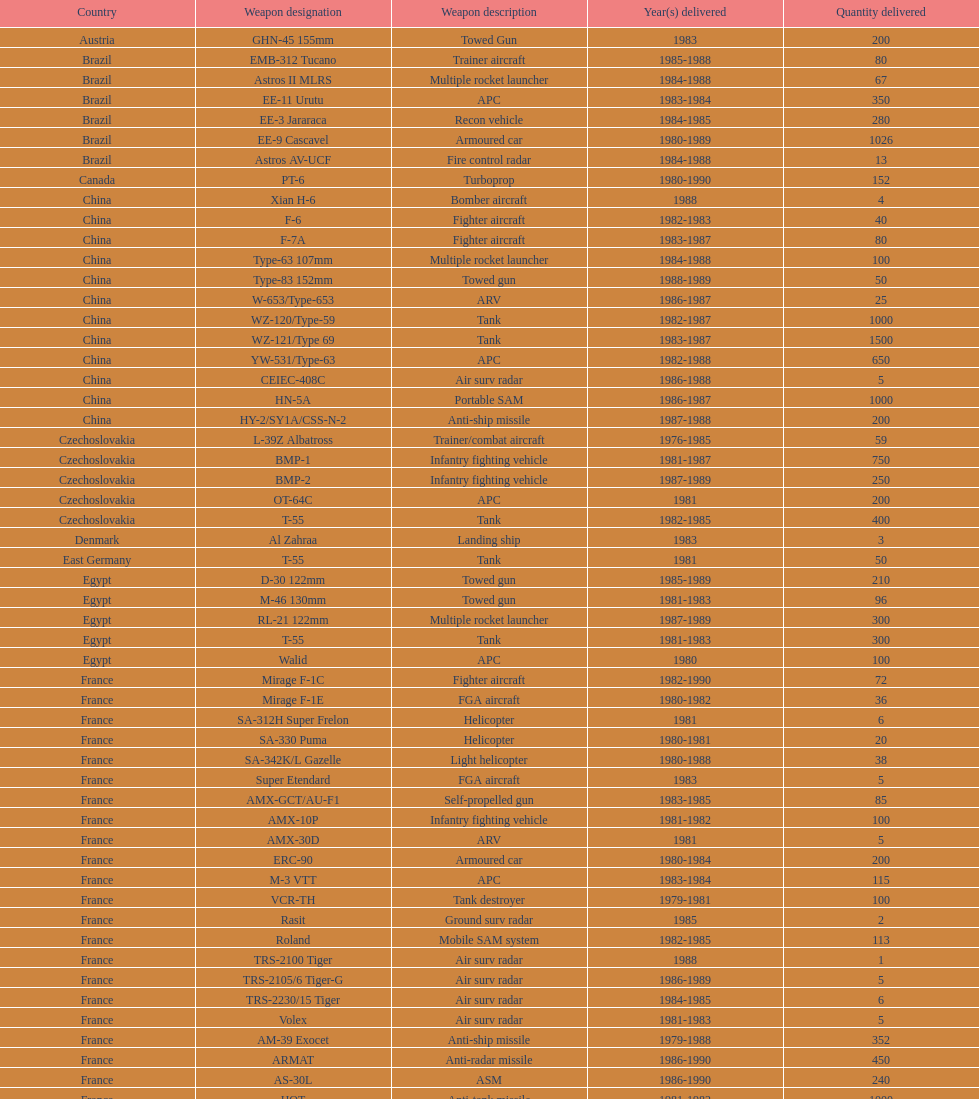What is the entire number of tanks provided by china to iraq? 2500. 